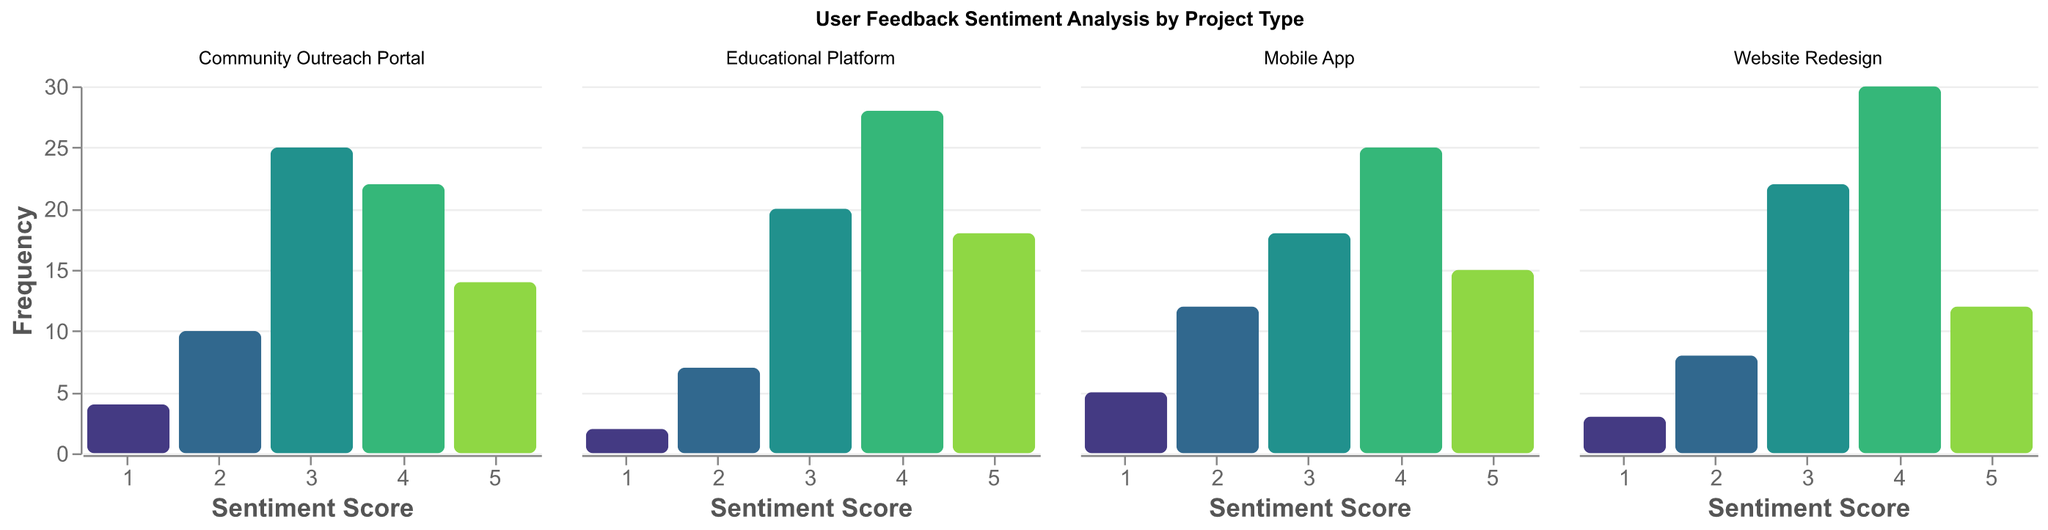What is the title of the figure? The title of the figure is displayed at the top and reads "User Feedback Sentiment Analysis by Project Type".
Answer: User Feedback Sentiment Analysis by Project Type How many project types are represented in the figure? There are four distinct subplots, each representing a different project type: Mobile App, Website Redesign, Educational Platform, and Community Outreach Portal.
Answer: Four Which project type has the highest frequency for sentiment score 4? By looking at the height of the bars corresponding to sentiment score 4, Website Redesign has the highest bar with a frequency of 30.
Answer: Website Redesign Which sentiment score has the lowest frequency for the Educational Platform project type? The bar corresponding to sentiment score 1 has the lowest height in the Educational Platform subplot, indicating a frequency of 2.
Answer: 1 Compare the frequency of sentiment score 3 between Mobile App and Community Outreach Portal. Which one is higher? The bars corresponding to sentiment score 3 in the Mobile App and Community Outreach Portal subplots show frequencies of 18 and 25, respectively. So, Community Outreach Portal is higher.
Answer: Community Outreach Portal What is the total frequency for sentiment scores in the Mobile App project type? Adding up all frequencies for sentiment scores 1 through 5 in the Mobile App subplot: 5 + 12 + 18 + 25 + 15 = 75.
Answer: 75 For the Community Outreach Portal project type, what is the difference in frequency between sentiment scores 2 and 4? The frequencies for sentiment scores 2 and 4 in the Community Outreach Portal subplot are 10 and 22, respectively. The difference is 22 - 10 = 12.
Answer: 12 Which sentiment score has the highest frequency across all project types? By looking at the highest bar for each subplot, sentiment score 4 in the Website Redesign subplot has the highest frequency of 30.
Answer: 4 What is the average frequency of sentiment scores for the Website Redesign project type? Adding all frequencies for sentiment scores 1 through 5 in the Website Redesign subplot: (3 + 8 + 22 + 30 + 12) = 75. Dividing by 5 gives an average of 75 / 5 = 15.
Answer: 15 